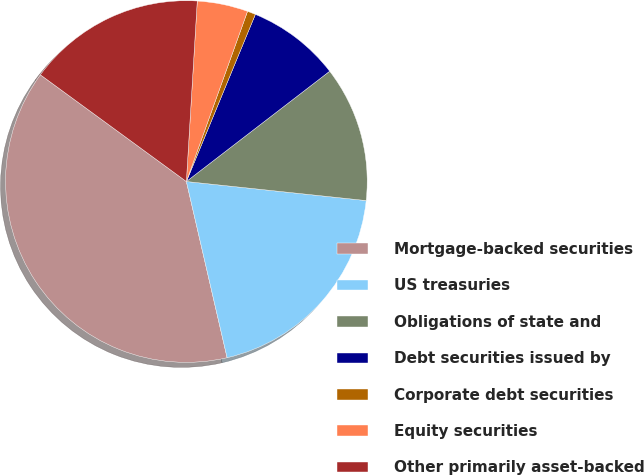<chart> <loc_0><loc_0><loc_500><loc_500><pie_chart><fcel>Mortgage-backed securities<fcel>US treasuries<fcel>Obligations of state and<fcel>Debt securities issued by<fcel>Corporate debt securities<fcel>Equity securities<fcel>Other primarily asset-backed<nl><fcel>38.66%<fcel>19.7%<fcel>12.12%<fcel>8.33%<fcel>0.74%<fcel>4.53%<fcel>15.91%<nl></chart> 